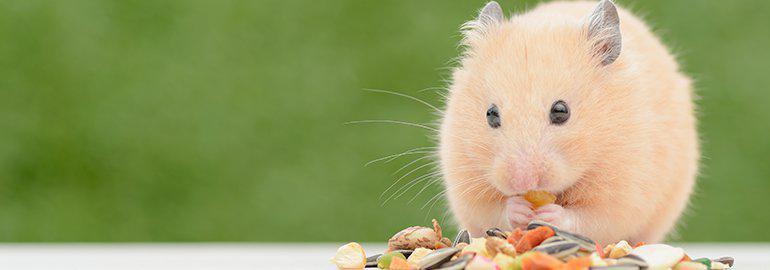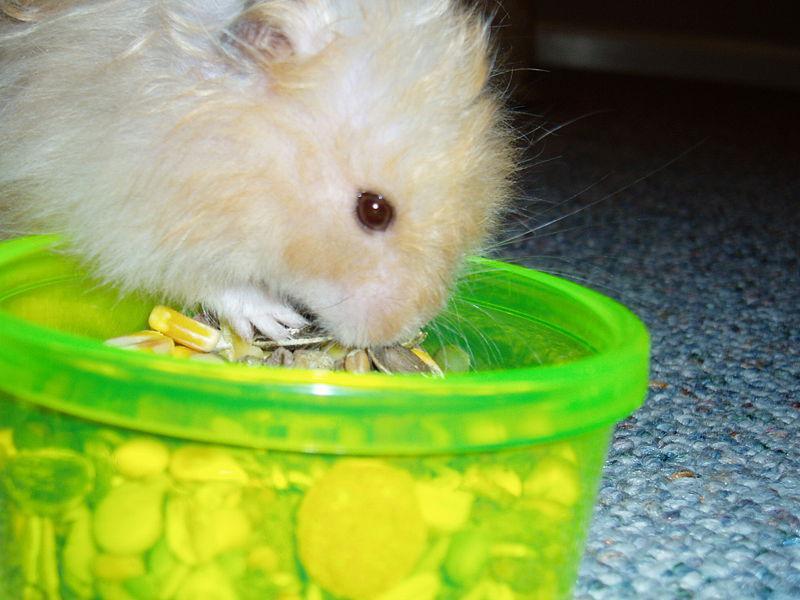The first image is the image on the left, the second image is the image on the right. For the images shown, is this caption "The hamsters in each image appear sort of orangish, and the ones pictured by themselves also have some food they are eating." true? Answer yes or no. Yes. The first image is the image on the left, the second image is the image on the right. For the images displayed, is the sentence "An image shows one hamster on the right of a round object with orange-red coloring." factually correct? Answer yes or no. No. 